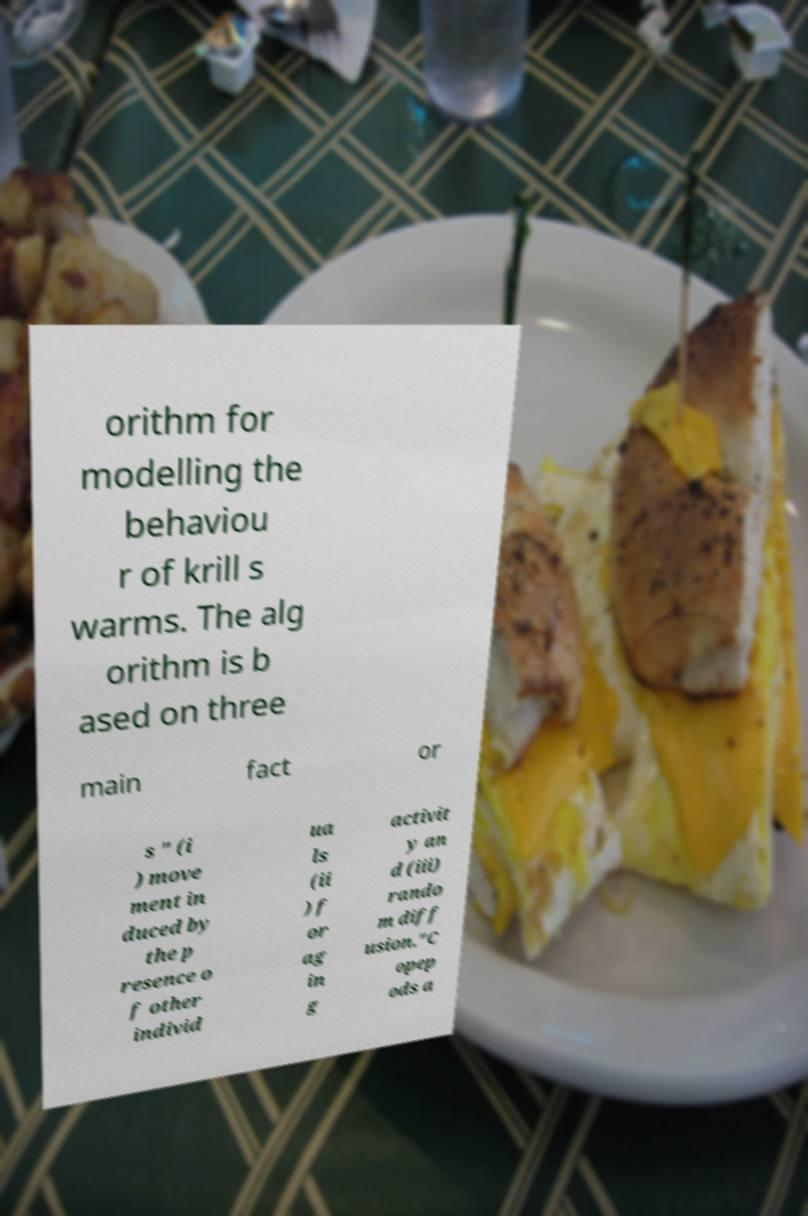Can you read and provide the text displayed in the image?This photo seems to have some interesting text. Can you extract and type it out for me? orithm for modelling the behaviou r of krill s warms. The alg orithm is b ased on three main fact or s " (i ) move ment in duced by the p resence o f other individ ua ls (ii ) f or ag in g activit y an d (iii) rando m diff usion."C opep ods a 